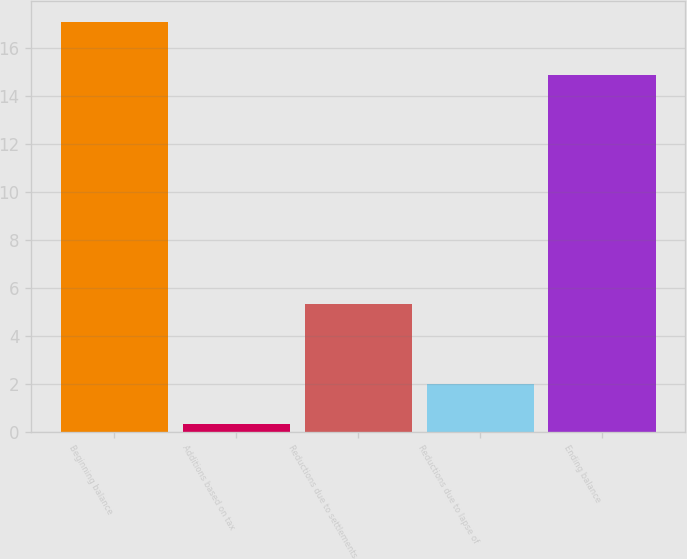Convert chart. <chart><loc_0><loc_0><loc_500><loc_500><bar_chart><fcel>Beginning balance<fcel>Additions based on tax<fcel>Reductions due to settlements<fcel>Reductions due to lapse of<fcel>Ending balance<nl><fcel>17.1<fcel>0.3<fcel>5.34<fcel>1.98<fcel>14.9<nl></chart> 